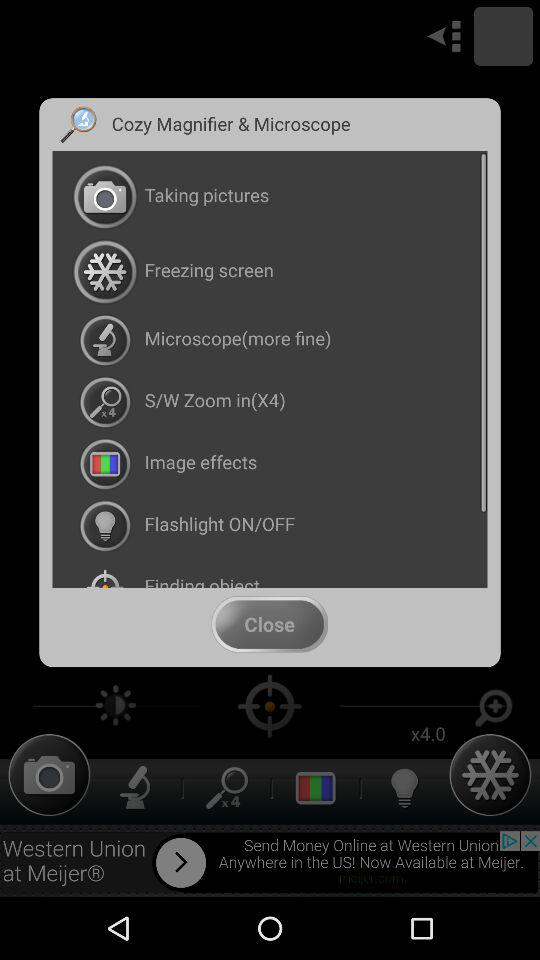What is the name of the application? The name of the application is "Cozy Magnifier & Microscope". 